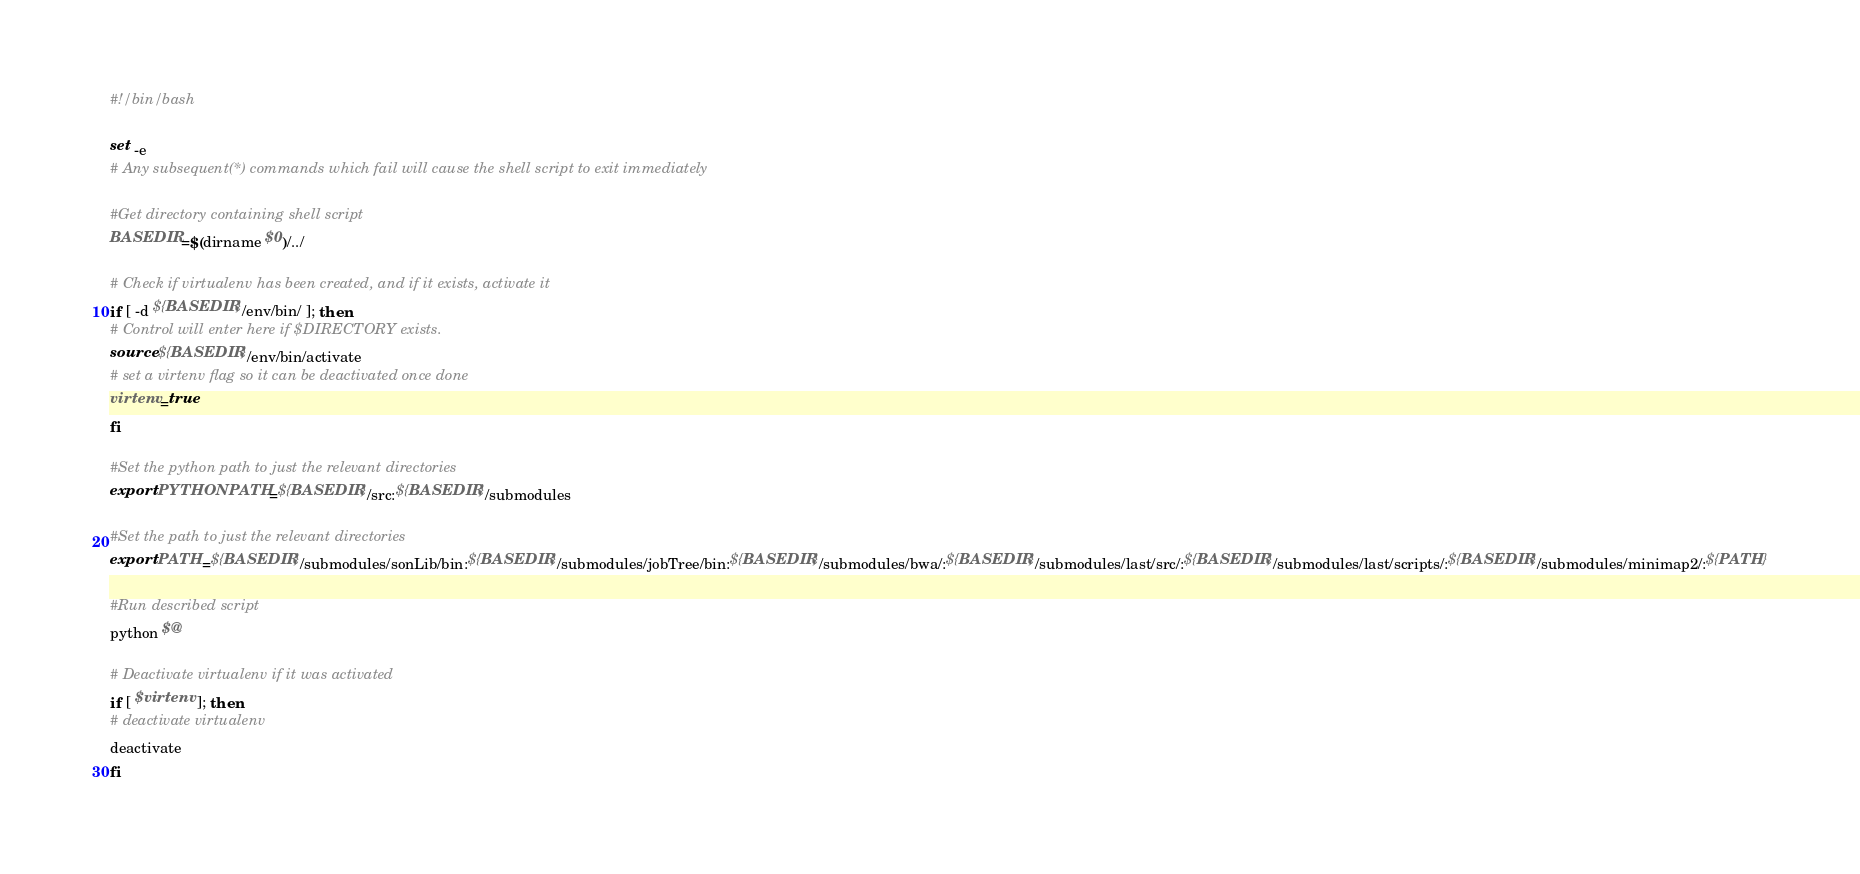<code> <loc_0><loc_0><loc_500><loc_500><_Bash_>#!/bin/bash

set -e
# Any subsequent(*) commands which fail will cause the shell script to exit immediately

#Get directory containing shell script
BASEDIR=$(dirname $0)/../

# Check if virtualenv has been created, and if it exists, activate it
if [ -d ${BASEDIR}/env/bin/ ]; then
# Control will enter here if $DIRECTORY exists.
source ${BASEDIR}/env/bin/activate
# set a virtenv flag so it can be deactivated once done
virtenv=true
fi

#Set the python path to just the relevant directories
export PYTHONPATH=${BASEDIR}/src:${BASEDIR}/submodules

#Set the path to just the relevant directories
export PATH=${BASEDIR}/submodules/sonLib/bin:${BASEDIR}/submodules/jobTree/bin:${BASEDIR}/submodules/bwa/:${BASEDIR}/submodules/last/src/:${BASEDIR}/submodules/last/scripts/:${BASEDIR}/submodules/minimap2/:${PATH}

#Run described script
python $@

# Deactivate virtualenv if it was activated
if [ $virtenv ]; then
# deactivate virtualenv
deactivate
fi
</code> 